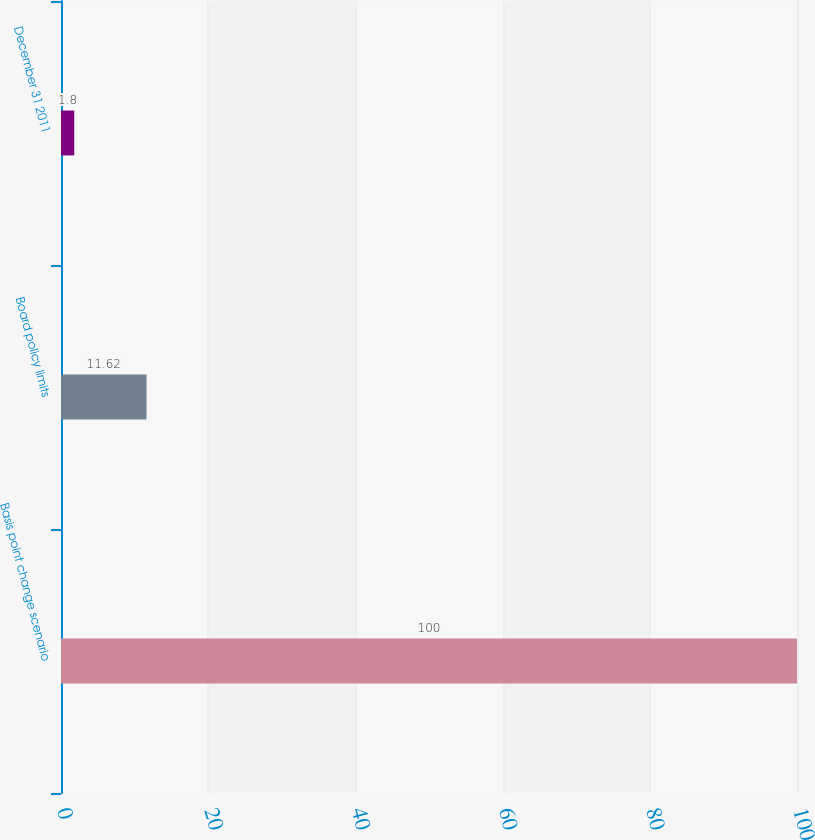Convert chart to OTSL. <chart><loc_0><loc_0><loc_500><loc_500><bar_chart><fcel>Basis point change scenario<fcel>Board policy limits<fcel>December 31 2011<nl><fcel>100<fcel>11.62<fcel>1.8<nl></chart> 